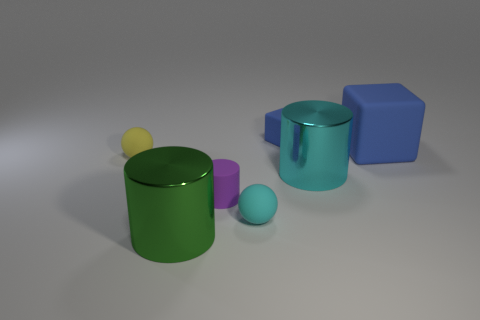Besides the spherical objects, what other shapes are present and what colors are they? Other than the spherical shapes, there is a cube-shaped object that is blue, and a cuboid or rectangular prism that appears to be colorless or transparent. 